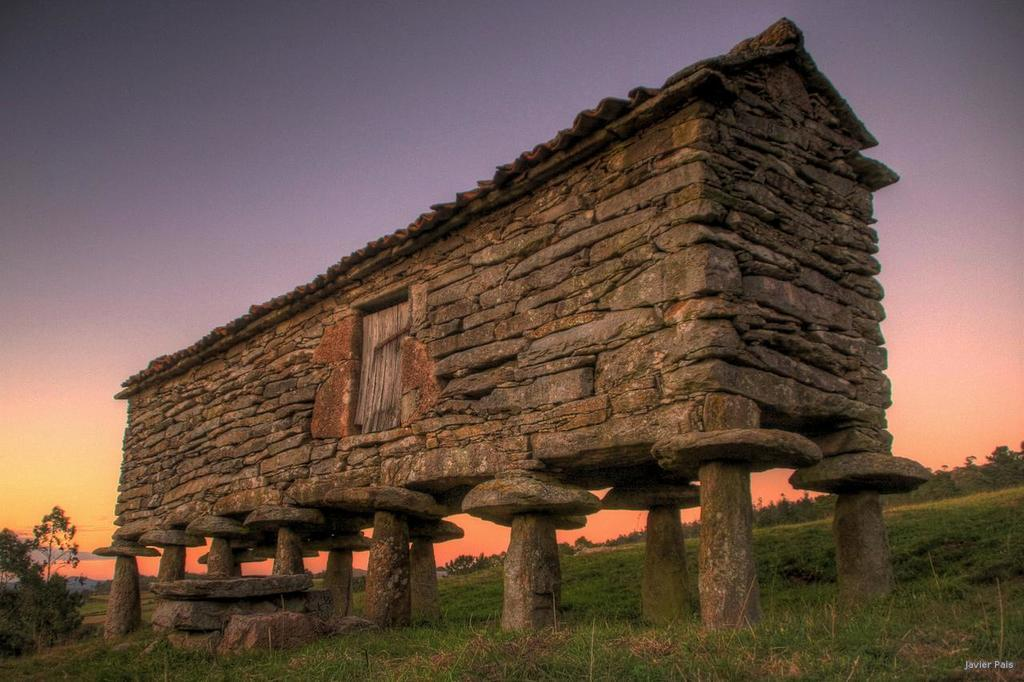What is the main structure visible in the foreground of the image? There is a hut in the foreground of the image. What is the hut standing on? The hut is standing on the grass. How is the hut supported? The hut is supported by pillars. What can be seen in the background of the image? There are trees and the sky visible in the background of the image. What is the condition of the sky in the image? The sky is visible with clouds in the background of the image. Can you tell me how many needles are sticking out of the hut in the image? There are no needles present in the image; the hut is supported by pillars. What type of walk is depicted in the image? There is no walk depicted in the image; it features a hut, grass, trees, and the sky. 